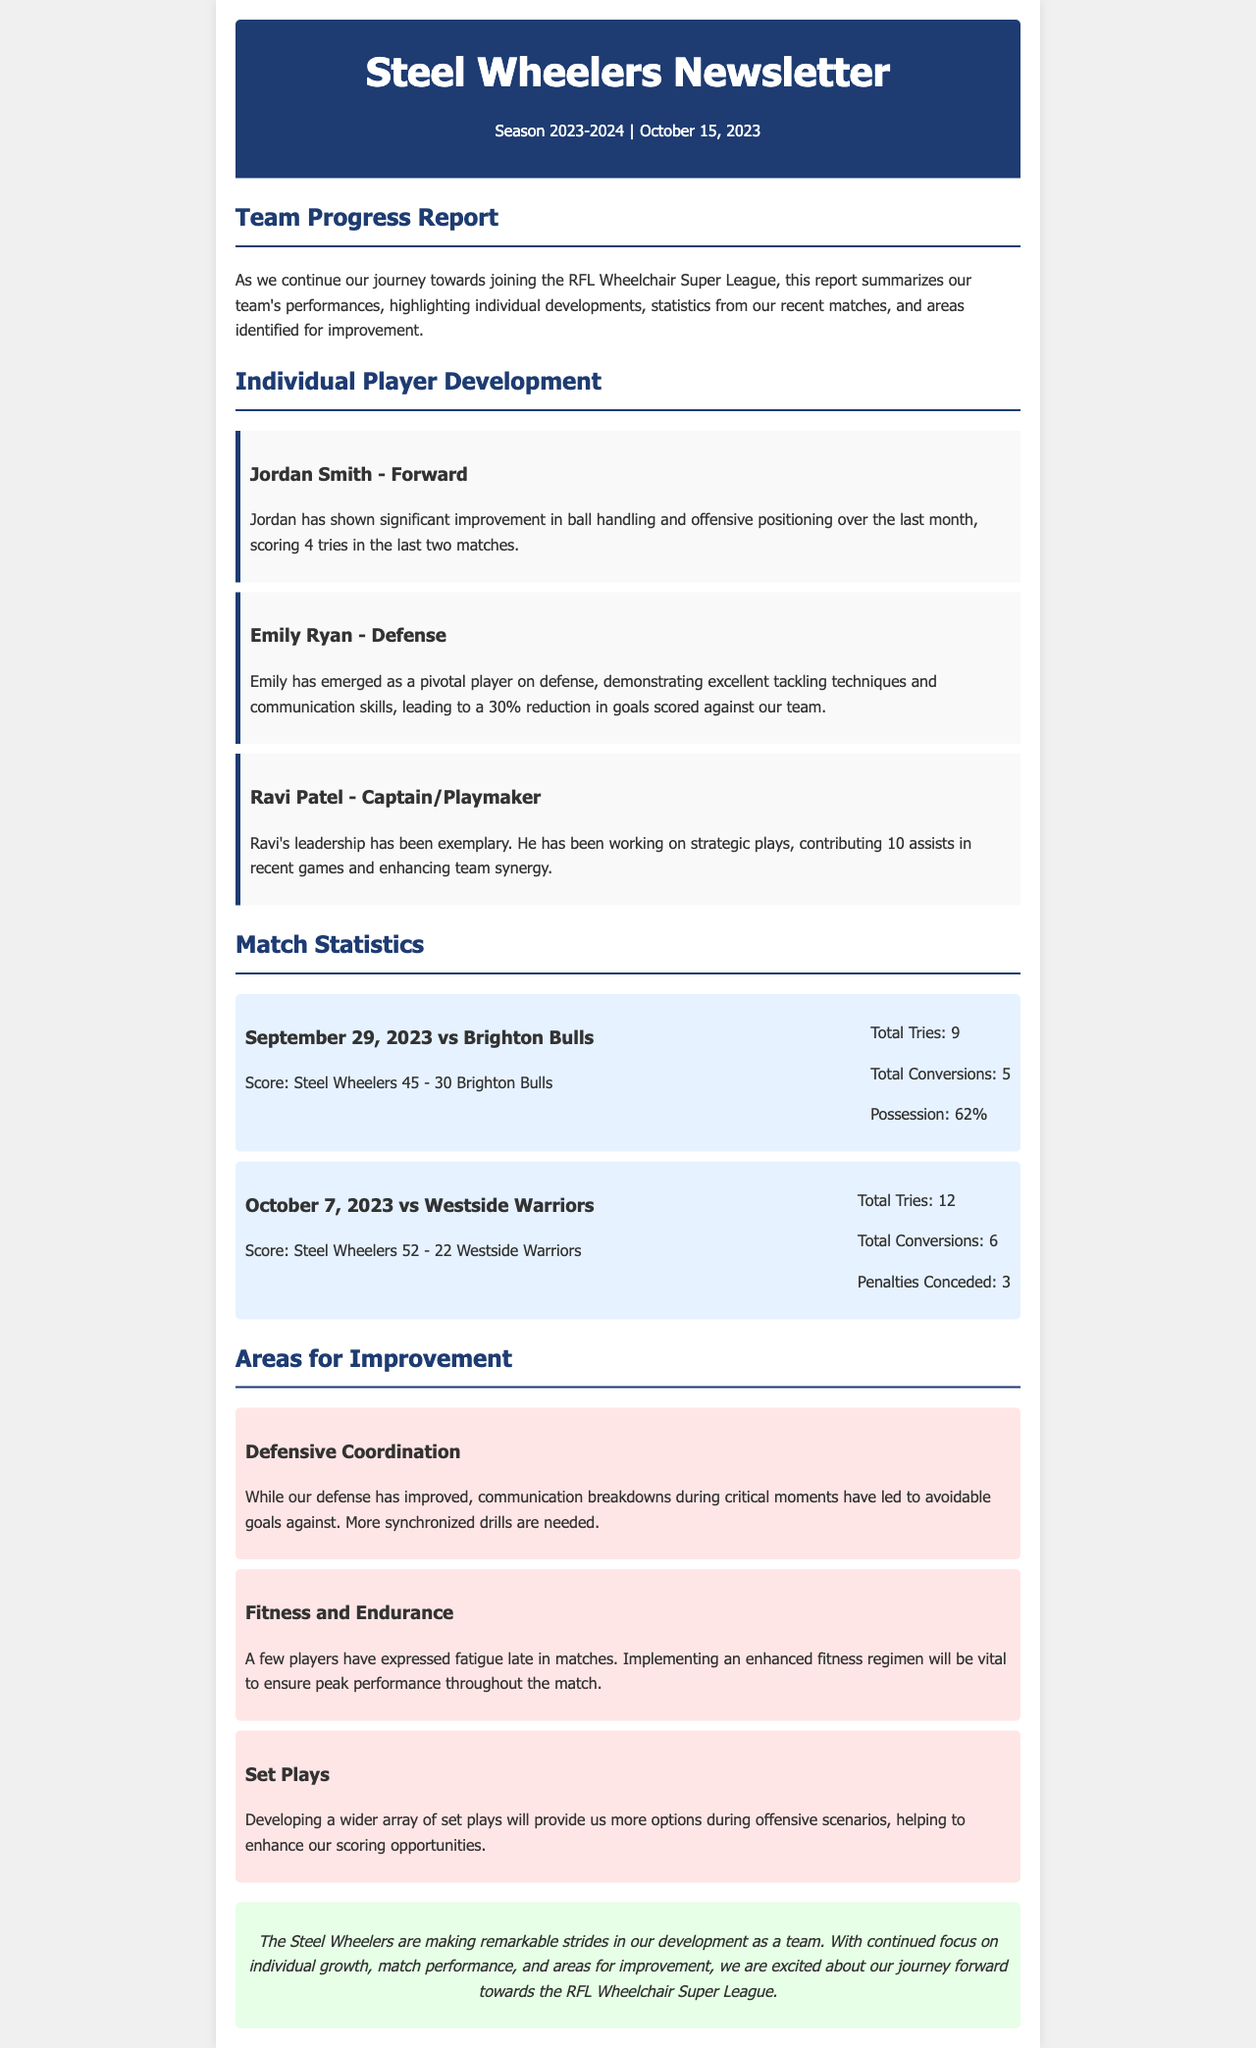What is the name of the team? The team is referred to as the Steel Wheelers in the document.
Answer: Steel Wheelers Who scored the most tries in the recent matches? Jordan Smith scored 4 tries in the last two matches, indicating he was a key player.
Answer: 4 tries What percentage of possession did the Steel Wheelers have against Brighton Bulls? The possession percentage against Brighton Bulls is highlighted in the match statistics section.
Answer: 62% What is a key area identified for improvement regarding defense? The document mentions communication breakdowns as a significant issue needing more synchronized drills.
Answer: Communication breakdowns How many assists did Ravi Patel contribute in recent games? Ravi's contributions in terms of assists are explicitly stated in his development section.
Answer: 10 assists Which player has demonstrated excellent tackling techniques? The document specifically mentions Emily Ryan as the player excelling in tackling.
Answer: Emily Ryan What is a recommended focus to enhance fitness for the players? The newsletter suggests implementing an enhanced fitness regimen as vital for performance.
Answer: Enhanced fitness regimen What was the score against Westside Warriors? The match score against Westside Warriors is detailed under match statistics.
Answer: 52 - 22 